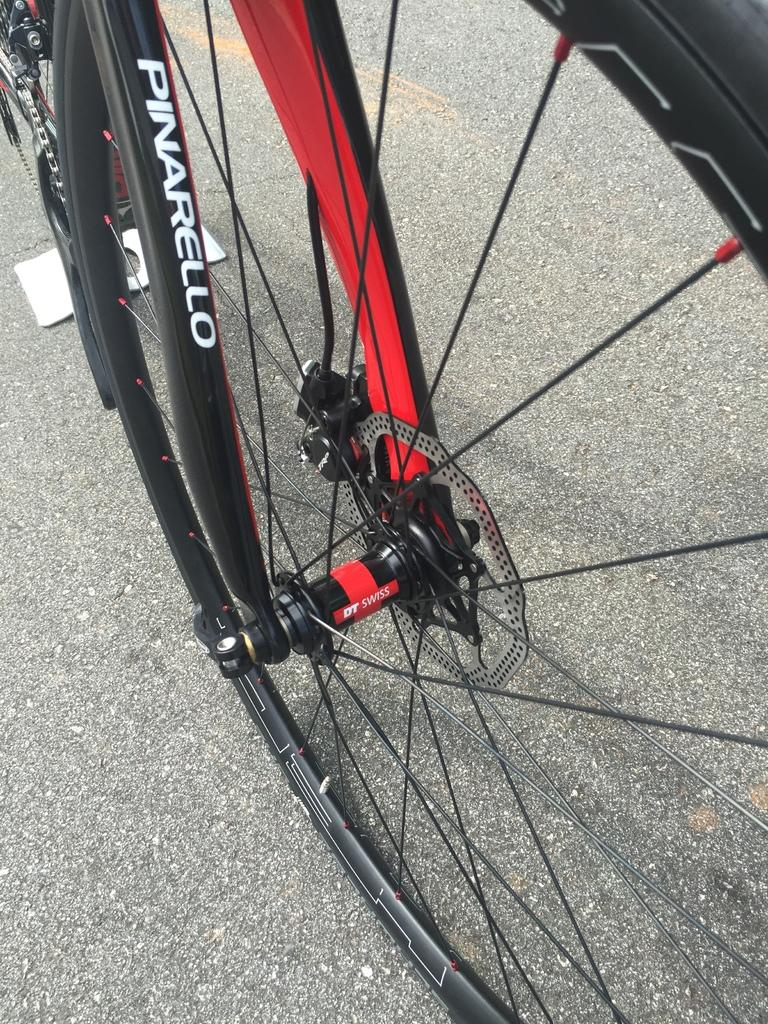What is the main subject of the image? The main subject of the image is a bicycle wheel. What colors are used in the bicycle wheel? The wheel is in black and red color. What type of furniture can be seen in the image? There is no furniture present in the image; it features a zoom-in of a bicycle wheel. Is there a baby visible in the image? There is no baby present in the image; it features a zoom-in of a bicycle wheel. 